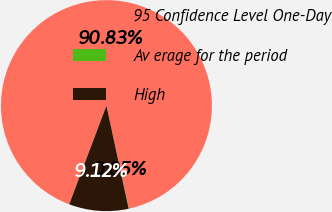Convert chart. <chart><loc_0><loc_0><loc_500><loc_500><pie_chart><fcel>95 Confidence Level One-Day<fcel>Av erage for the period<fcel>High<nl><fcel>90.83%<fcel>0.05%<fcel>9.12%<nl></chart> 